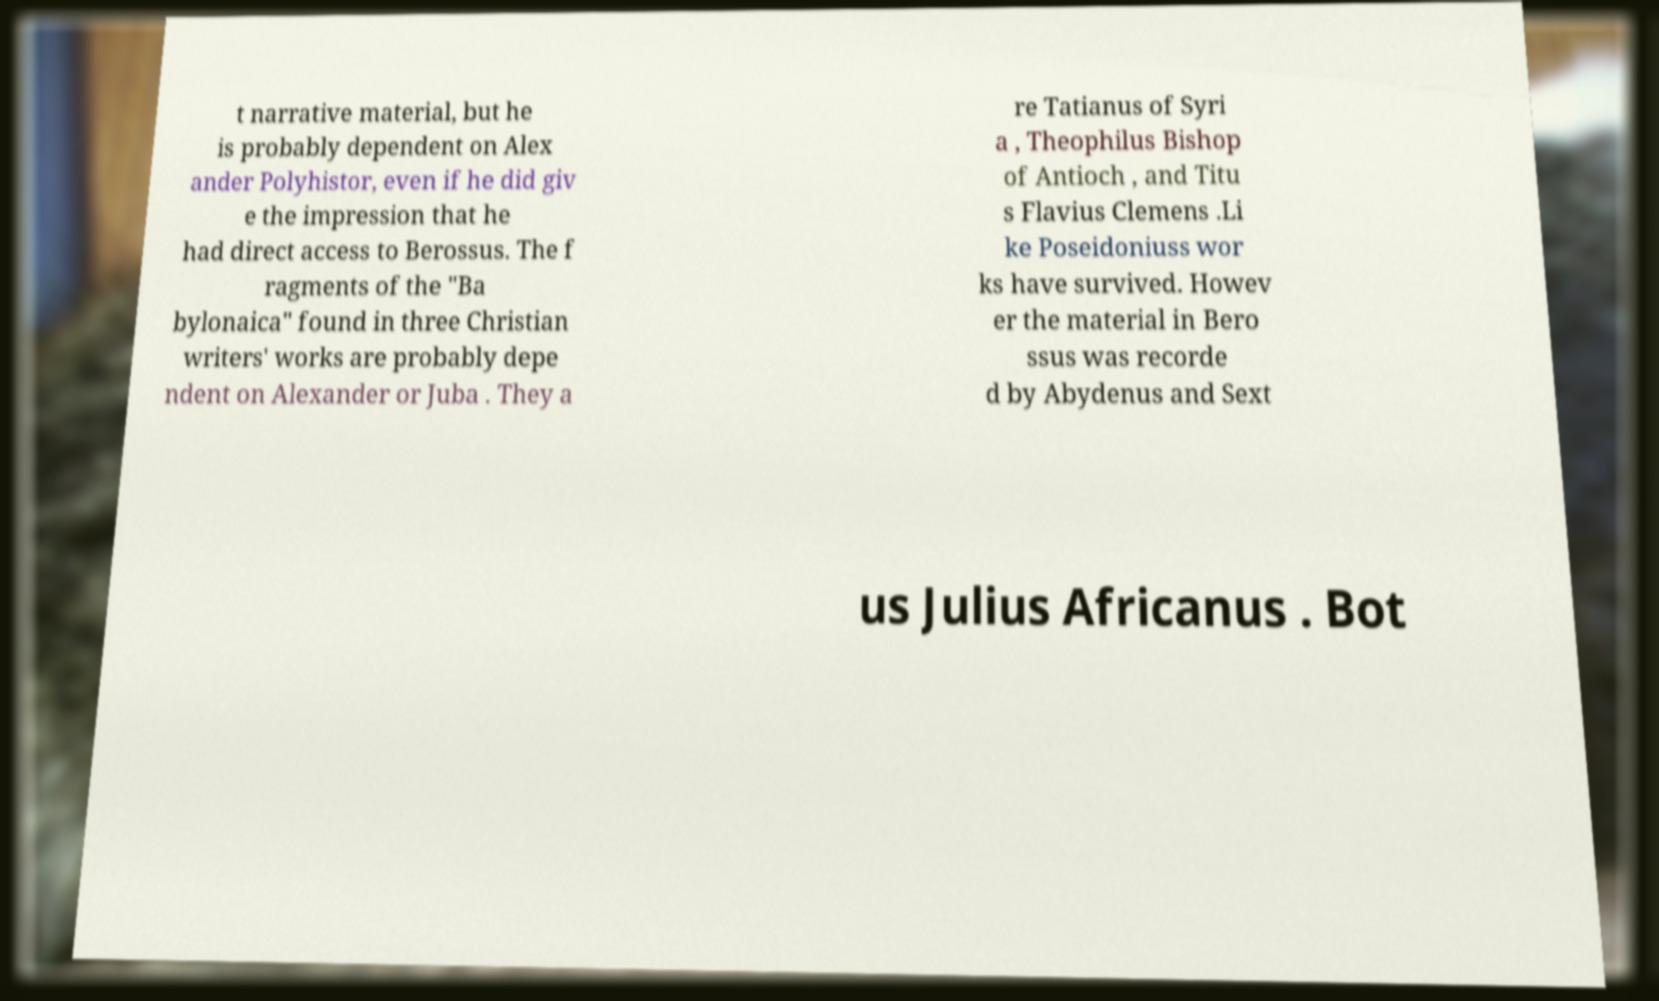There's text embedded in this image that I need extracted. Can you transcribe it verbatim? t narrative material, but he is probably dependent on Alex ander Polyhistor, even if he did giv e the impression that he had direct access to Berossus. The f ragments of the "Ba bylonaica" found in three Christian writers' works are probably depe ndent on Alexander or Juba . They a re Tatianus of Syri a , Theophilus Bishop of Antioch , and Titu s Flavius Clemens .Li ke Poseidoniuss wor ks have survived. Howev er the material in Bero ssus was recorde d by Abydenus and Sext us Julius Africanus . Bot 